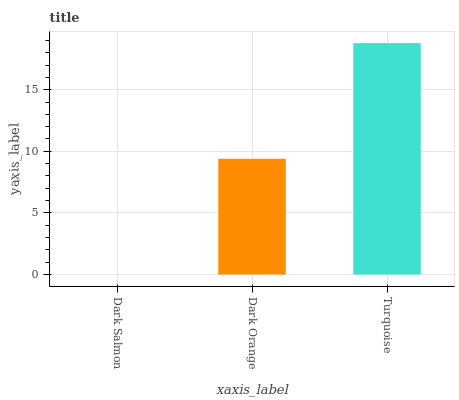Is Dark Salmon the minimum?
Answer yes or no. Yes. Is Turquoise the maximum?
Answer yes or no. Yes. Is Dark Orange the minimum?
Answer yes or no. No. Is Dark Orange the maximum?
Answer yes or no. No. Is Dark Orange greater than Dark Salmon?
Answer yes or no. Yes. Is Dark Salmon less than Dark Orange?
Answer yes or no. Yes. Is Dark Salmon greater than Dark Orange?
Answer yes or no. No. Is Dark Orange less than Dark Salmon?
Answer yes or no. No. Is Dark Orange the high median?
Answer yes or no. Yes. Is Dark Orange the low median?
Answer yes or no. Yes. Is Dark Salmon the high median?
Answer yes or no. No. Is Dark Salmon the low median?
Answer yes or no. No. 